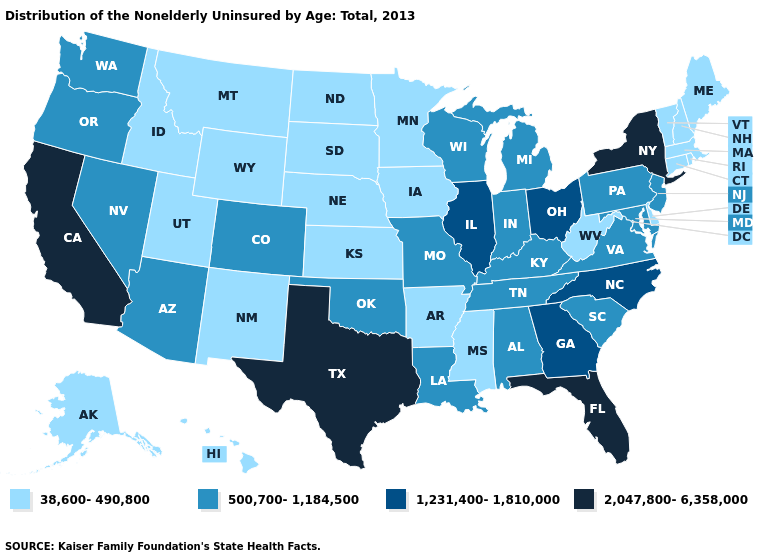Which states have the lowest value in the South?
Write a very short answer. Arkansas, Delaware, Mississippi, West Virginia. Name the states that have a value in the range 500,700-1,184,500?
Be succinct. Alabama, Arizona, Colorado, Indiana, Kentucky, Louisiana, Maryland, Michigan, Missouri, Nevada, New Jersey, Oklahoma, Oregon, Pennsylvania, South Carolina, Tennessee, Virginia, Washington, Wisconsin. Which states have the lowest value in the South?
Keep it brief. Arkansas, Delaware, Mississippi, West Virginia. What is the value of Washington?
Be succinct. 500,700-1,184,500. What is the highest value in the West ?
Give a very brief answer. 2,047,800-6,358,000. What is the value of Pennsylvania?
Answer briefly. 500,700-1,184,500. Does the first symbol in the legend represent the smallest category?
Quick response, please. Yes. Name the states that have a value in the range 1,231,400-1,810,000?
Quick response, please. Georgia, Illinois, North Carolina, Ohio. Name the states that have a value in the range 2,047,800-6,358,000?
Short answer required. California, Florida, New York, Texas. What is the highest value in the South ?
Give a very brief answer. 2,047,800-6,358,000. Does Colorado have the same value as Oregon?
Quick response, please. Yes. Does North Carolina have a higher value than Oklahoma?
Be succinct. Yes. Among the states that border Arkansas , does Texas have the highest value?
Concise answer only. Yes. Among the states that border Rhode Island , which have the lowest value?
Short answer required. Connecticut, Massachusetts. What is the highest value in the USA?
Short answer required. 2,047,800-6,358,000. 